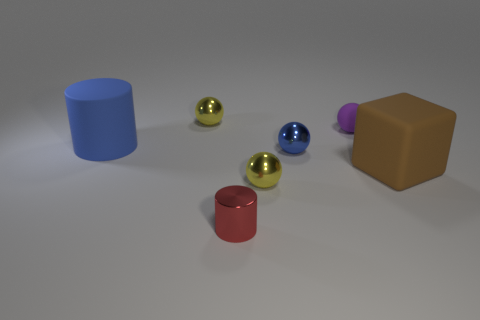What is the size of the matte thing that is on the left side of the brown matte block and on the right side of the red object? The matte object to the left of the brown block and the right of the red object is relatively small, roughly comparable in size to the colored spheres nearby, but smaller than the nearby blocks and cylinders. 